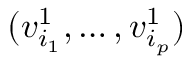<formula> <loc_0><loc_0><loc_500><loc_500>( v _ { i _ { 1 } } ^ { 1 } , \dots , v _ { i _ { p } } ^ { 1 } )</formula> 